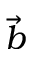Convert formula to latex. <formula><loc_0><loc_0><loc_500><loc_500>\vec { b }</formula> 